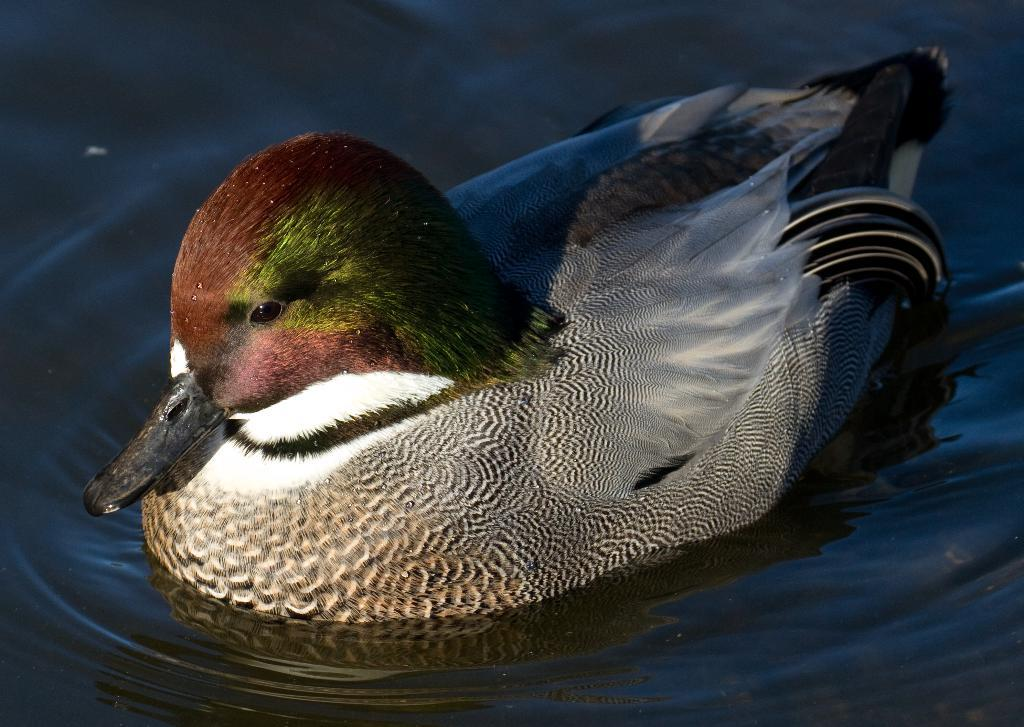What animal can be seen in the image? There is a duck in the image. Where is the duck located? The duck is in the water. What type of fork can be seen in the image? There is no fork present in the image; it features a duck in the water. What kind of horn is visible on the duck's head in the image? Ducks do not have horns, and there is no horn visible on the duck's head in the image. 